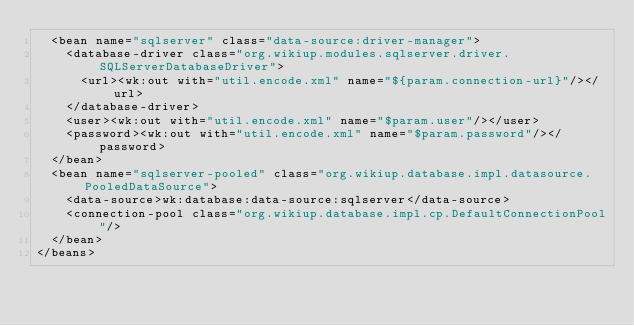<code> <loc_0><loc_0><loc_500><loc_500><_XML_>  <bean name="sqlserver" class="data-source:driver-manager">
    <database-driver class="org.wikiup.modules.sqlserver.driver.SQLServerDatabaseDriver">
      <url><wk:out with="util.encode.xml" name="${param.connection-url}"/></url>
    </database-driver>
    <user><wk:out with="util.encode.xml" name="$param.user"/></user>
    <password><wk:out with="util.encode.xml" name="$param.password"/></password>
  </bean>
  <bean name="sqlserver-pooled" class="org.wikiup.database.impl.datasource.PooledDataSource">
    <data-source>wk:database:data-source:sqlserver</data-source>
    <connection-pool class="org.wikiup.database.impl.cp.DefaultConnectionPool"/>
  </bean>
</beans>
</code> 